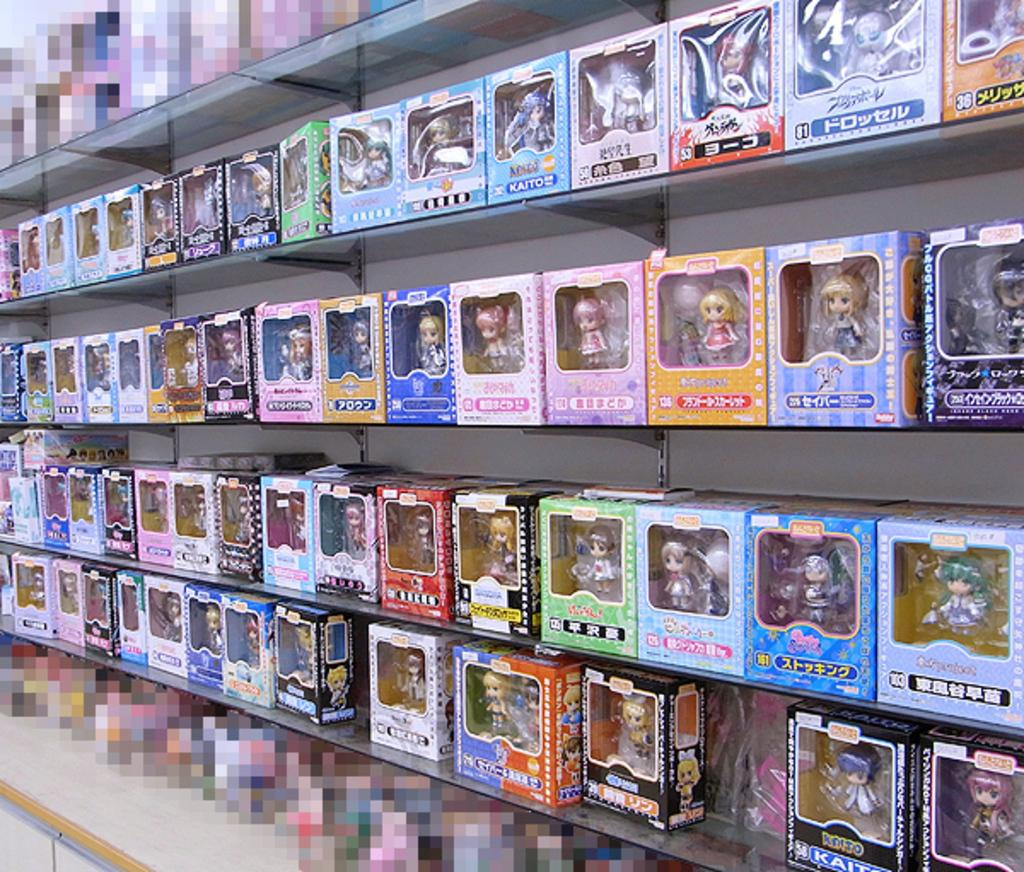Provide a one-sentence caption for the provided image. Toys on a shelf with different numbers like 81. 